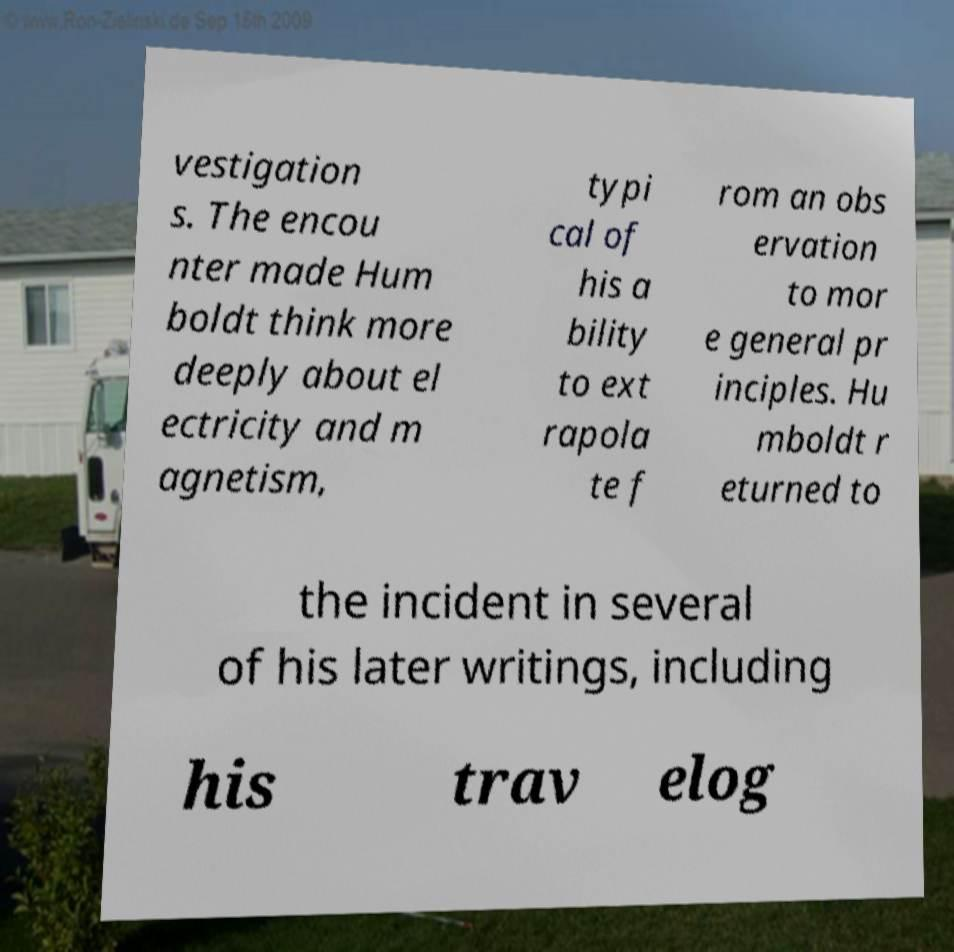Could you extract and type out the text from this image? vestigation s. The encou nter made Hum boldt think more deeply about el ectricity and m agnetism, typi cal of his a bility to ext rapola te f rom an obs ervation to mor e general pr inciples. Hu mboldt r eturned to the incident in several of his later writings, including his trav elog 